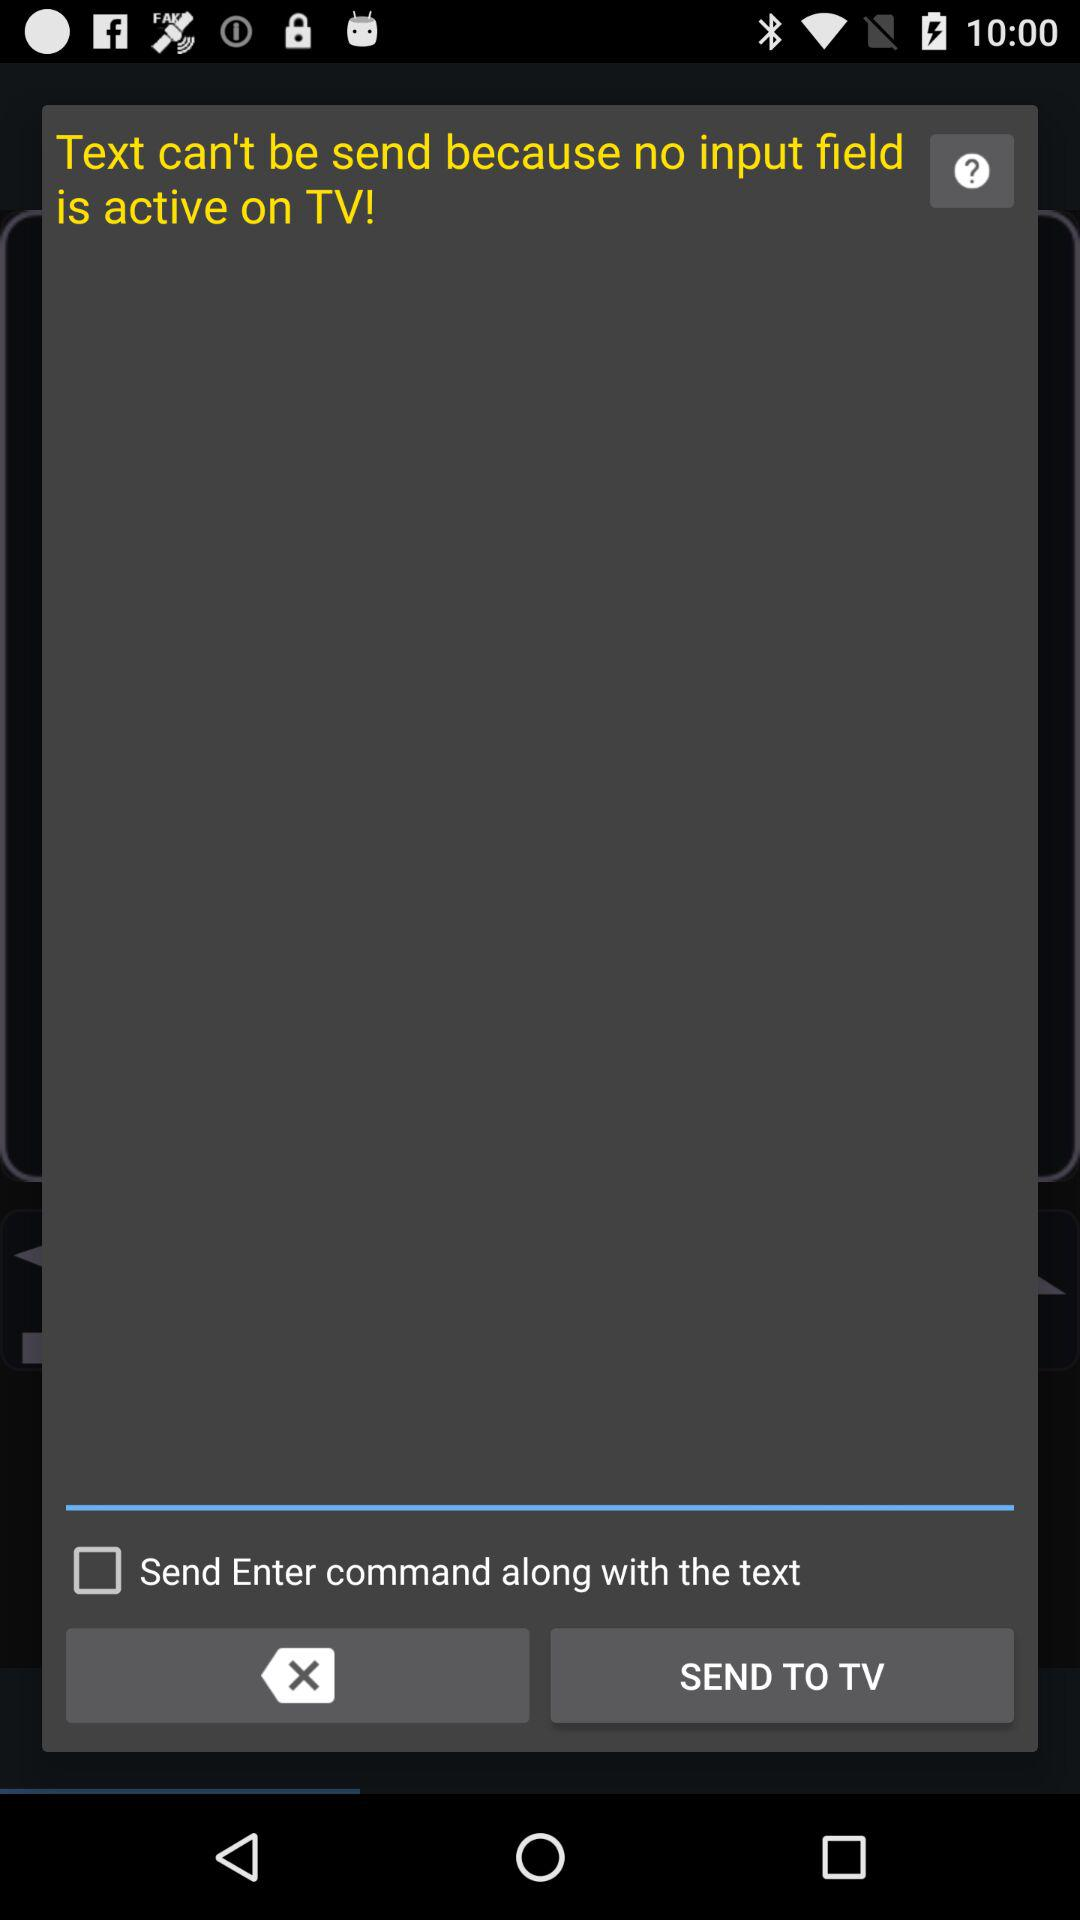How many input fields are active on the TV?
Answer the question using a single word or phrase. 0 